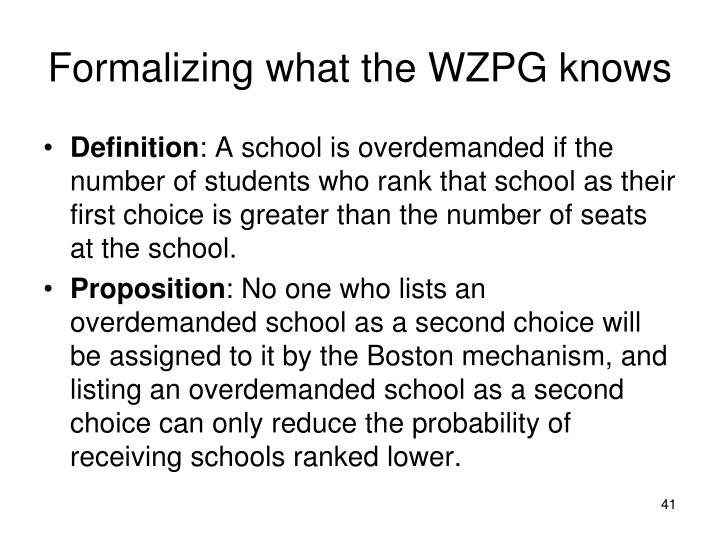What implications does the proposition have on the strategy that students might use when ranking schools? Based solely on the information provided in the image, the proposition implies that students should be strategic in ranking their school choices. If a student lists an overdemanded school as their second choice, it will not increase their chances of getting into that school, and may in fact decrease their chances of getting into other schools that are ranked lower. Therefore, students may be better served by ranking less-demanded schools higher on their list to maximize their chances of getting into a good school. This suggests that understanding the demand for each school is crucial when students are listing their preferences. 